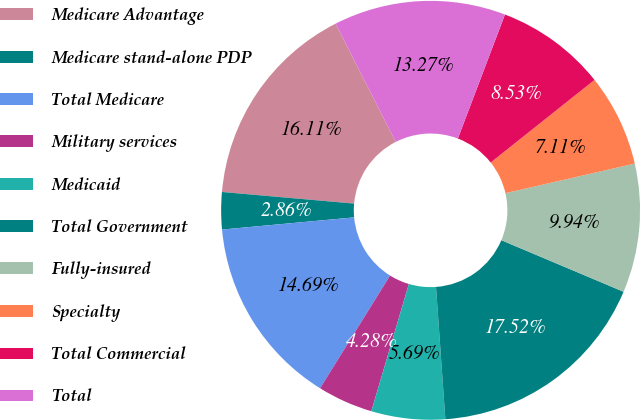Convert chart. <chart><loc_0><loc_0><loc_500><loc_500><pie_chart><fcel>Medicare Advantage<fcel>Medicare stand-alone PDP<fcel>Total Medicare<fcel>Military services<fcel>Medicaid<fcel>Total Government<fcel>Fully-insured<fcel>Specialty<fcel>Total Commercial<fcel>Total<nl><fcel>16.11%<fcel>2.86%<fcel>14.69%<fcel>4.28%<fcel>5.69%<fcel>17.52%<fcel>9.94%<fcel>7.11%<fcel>8.53%<fcel>13.27%<nl></chart> 